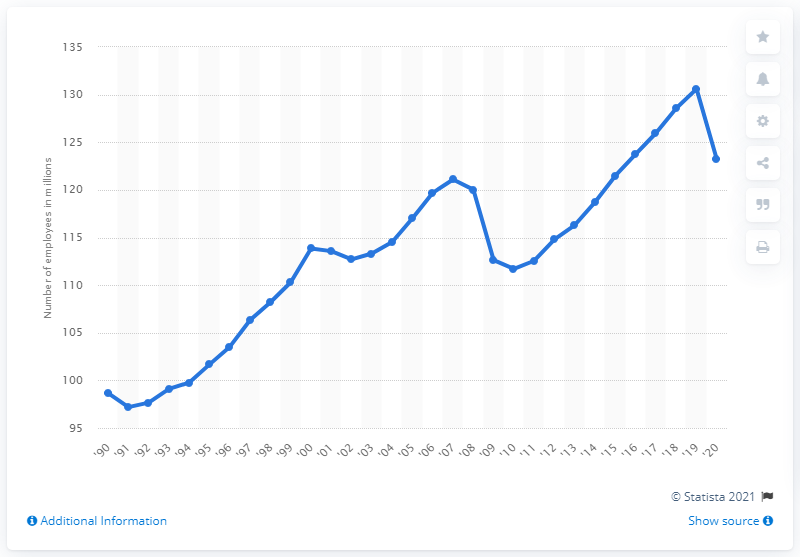Outline some significant characteristics in this image. In the year 2020, a total of 123.19 full-time employees were employed in the United States. 